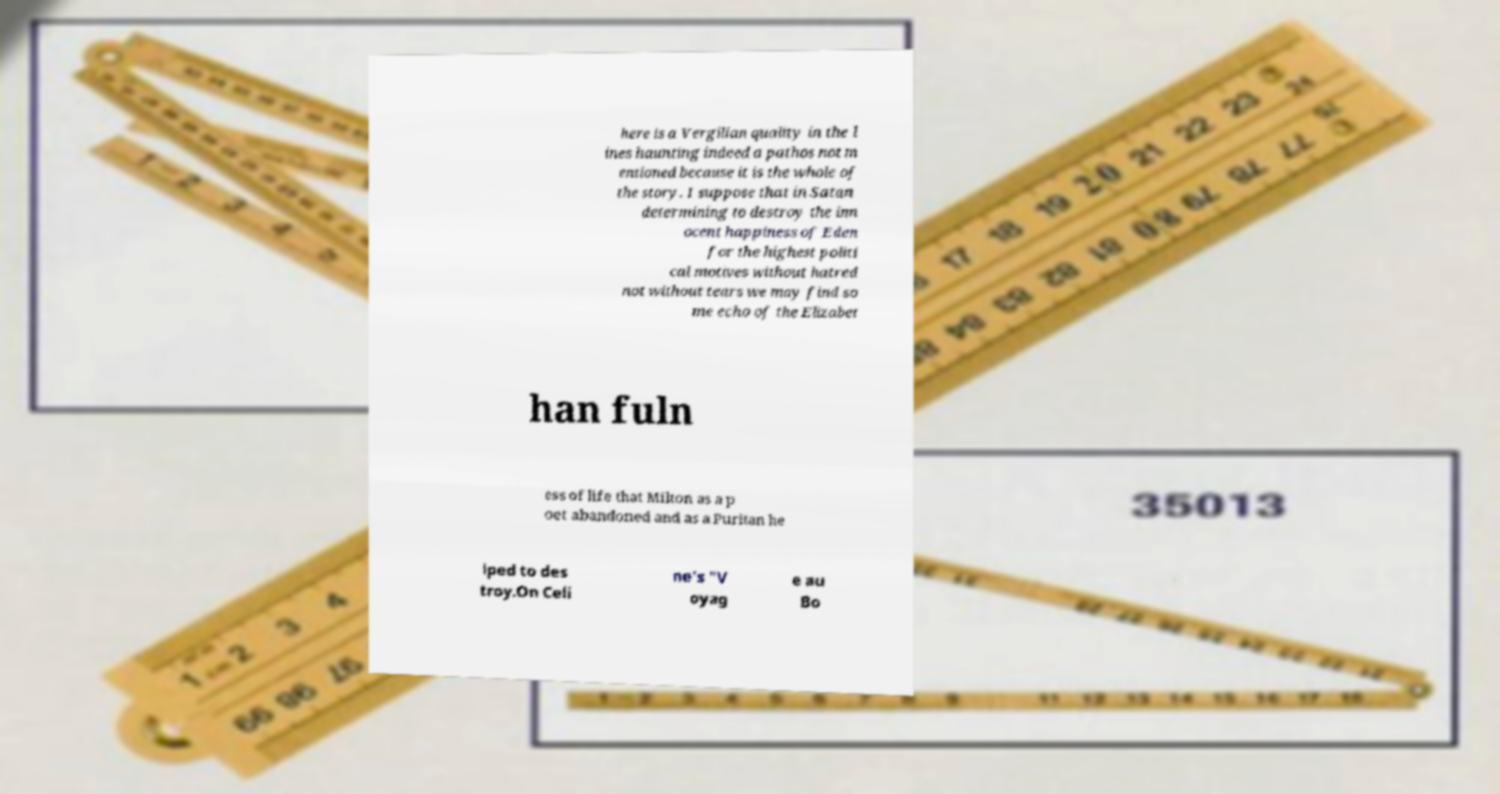For documentation purposes, I need the text within this image transcribed. Could you provide that? here is a Vergilian quality in the l ines haunting indeed a pathos not m entioned because it is the whole of the story. I suppose that in Satan determining to destroy the inn ocent happiness of Eden for the highest politi cal motives without hatred not without tears we may find so me echo of the Elizabet han fuln ess of life that Milton as a p oet abandoned and as a Puritan he lped to des troy.On Celi ne's "V oyag e au Bo 